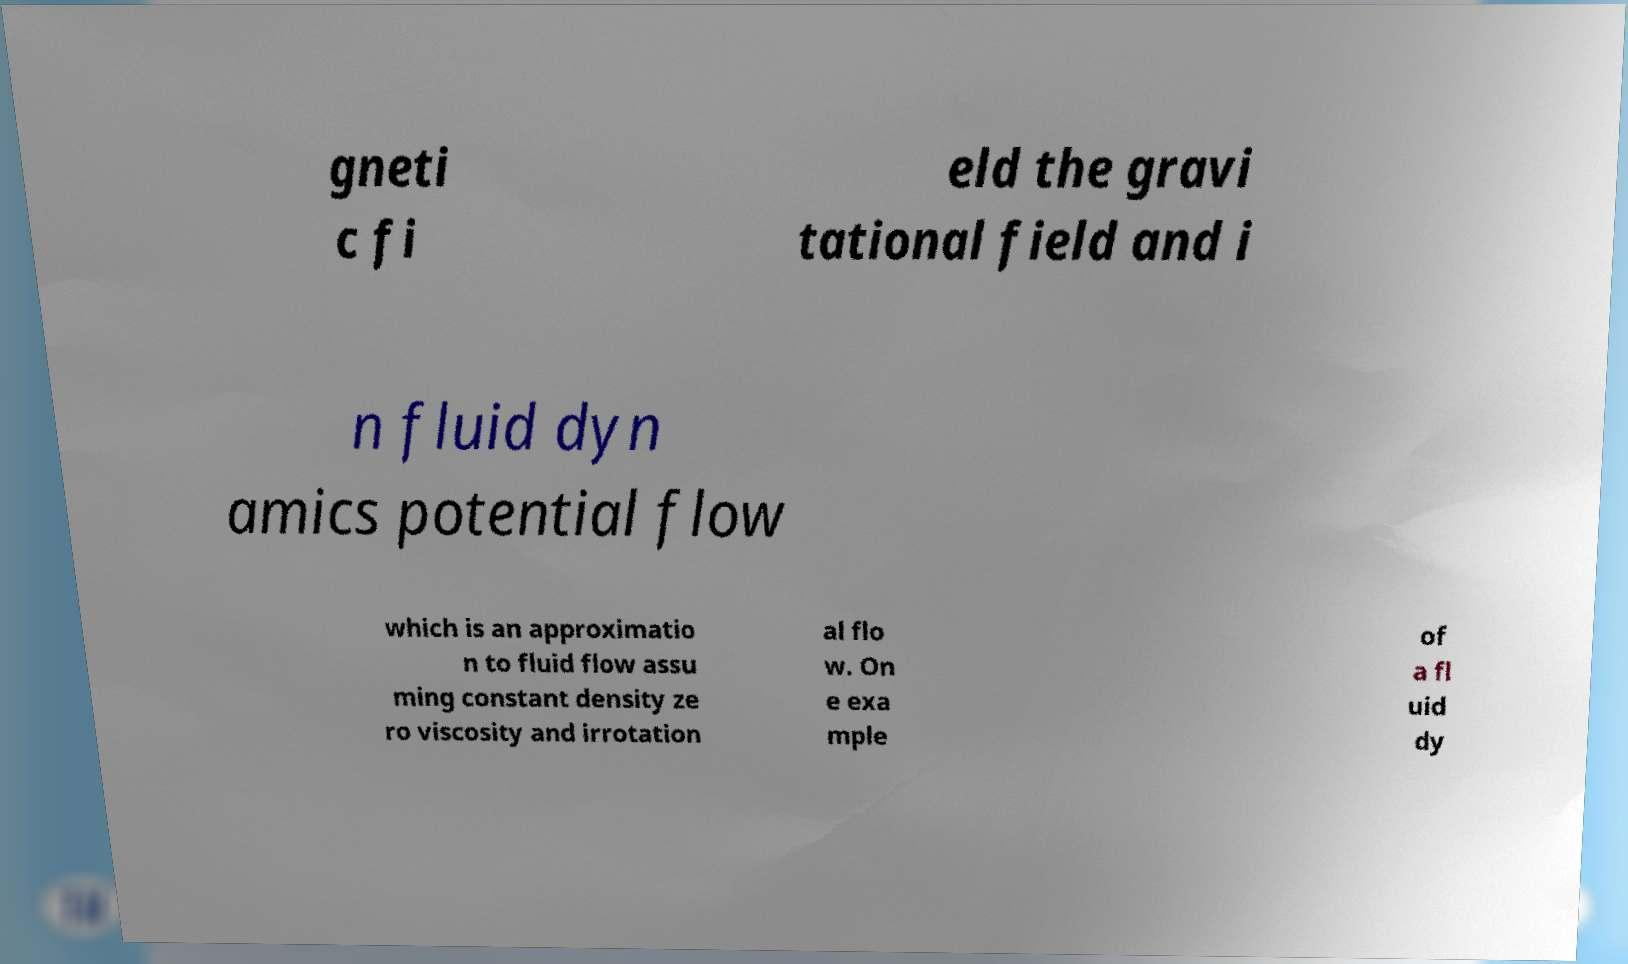Please read and relay the text visible in this image. What does it say? gneti c fi eld the gravi tational field and i n fluid dyn amics potential flow which is an approximatio n to fluid flow assu ming constant density ze ro viscosity and irrotation al flo w. On e exa mple of a fl uid dy 